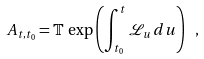<formula> <loc_0><loc_0><loc_500><loc_500>A _ { t , t _ { 0 } } = \mathbb { T } \, \exp \left ( \int _ { t _ { 0 } } ^ { t } \mathcal { L } _ { u } \, d u \right ) \ ,</formula> 